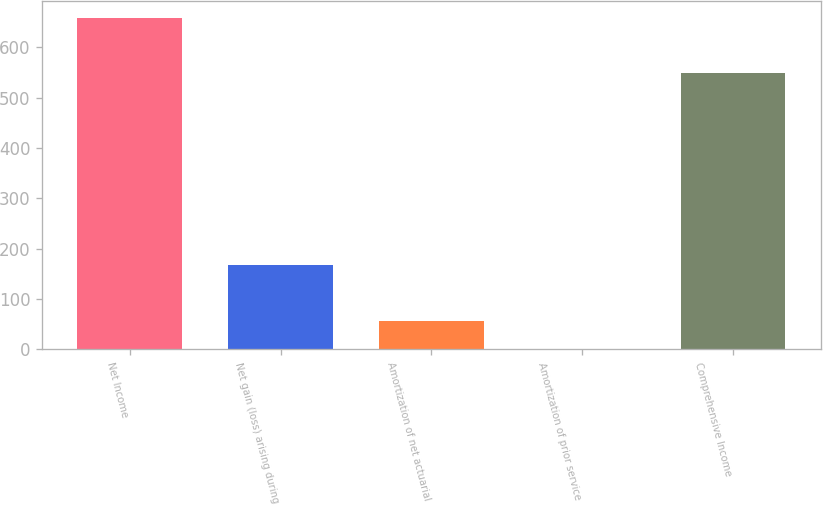Convert chart. <chart><loc_0><loc_0><loc_500><loc_500><bar_chart><fcel>Net Income<fcel>Net gain (loss) arising during<fcel>Amortization of net actuarial<fcel>Amortization of prior service<fcel>Comprehensive Income<nl><fcel>658.4<fcel>166.6<fcel>56.2<fcel>1<fcel>548<nl></chart> 